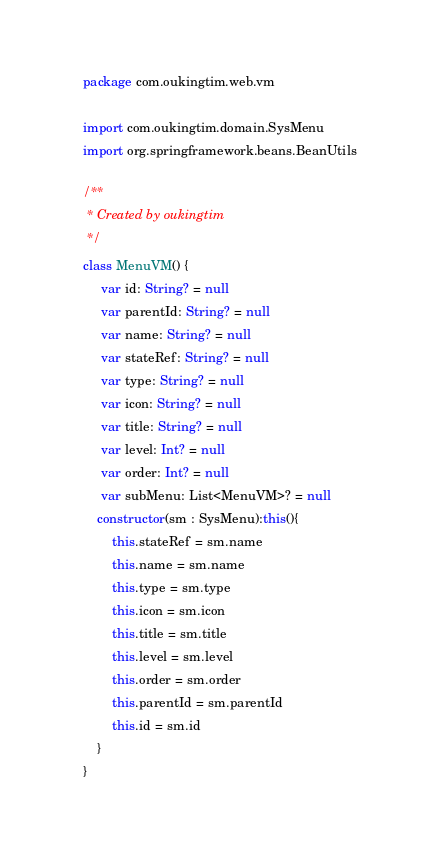Convert code to text. <code><loc_0><loc_0><loc_500><loc_500><_Kotlin_>package com.oukingtim.web.vm

import com.oukingtim.domain.SysMenu
import org.springframework.beans.BeanUtils

/**
 * Created by oukingtim
 */
class MenuVM() {
     var id: String? = null
     var parentId: String? = null
     var name: String? = null
     var stateRef: String? = null
     var type: String? = null
     var icon: String? = null
     var title: String? = null
     var level: Int? = null
     var order: Int? = null
     var subMenu: List<MenuVM>? = null
    constructor(sm : SysMenu):this(){
        this.stateRef = sm.name
        this.name = sm.name
        this.type = sm.type
        this.icon = sm.icon
        this.title = sm.title
        this.level = sm.level
        this.order = sm.order
        this.parentId = sm.parentId
        this.id = sm.id
    }
}</code> 